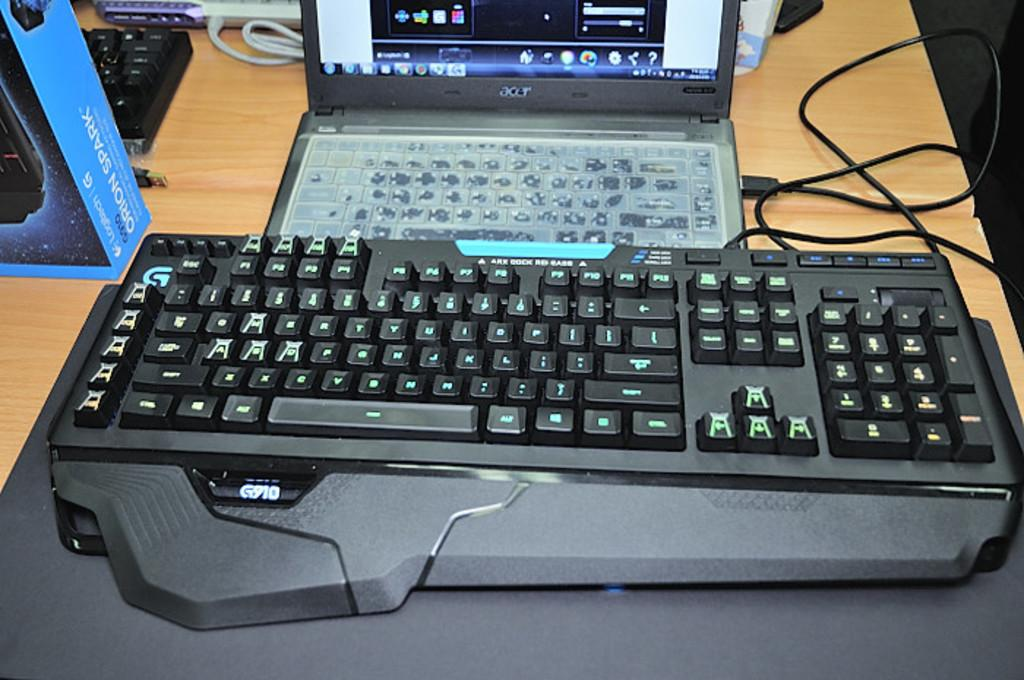<image>
Give a short and clear explanation of the subsequent image. An Acer brand laptop is hooked to a giant keyboard. 